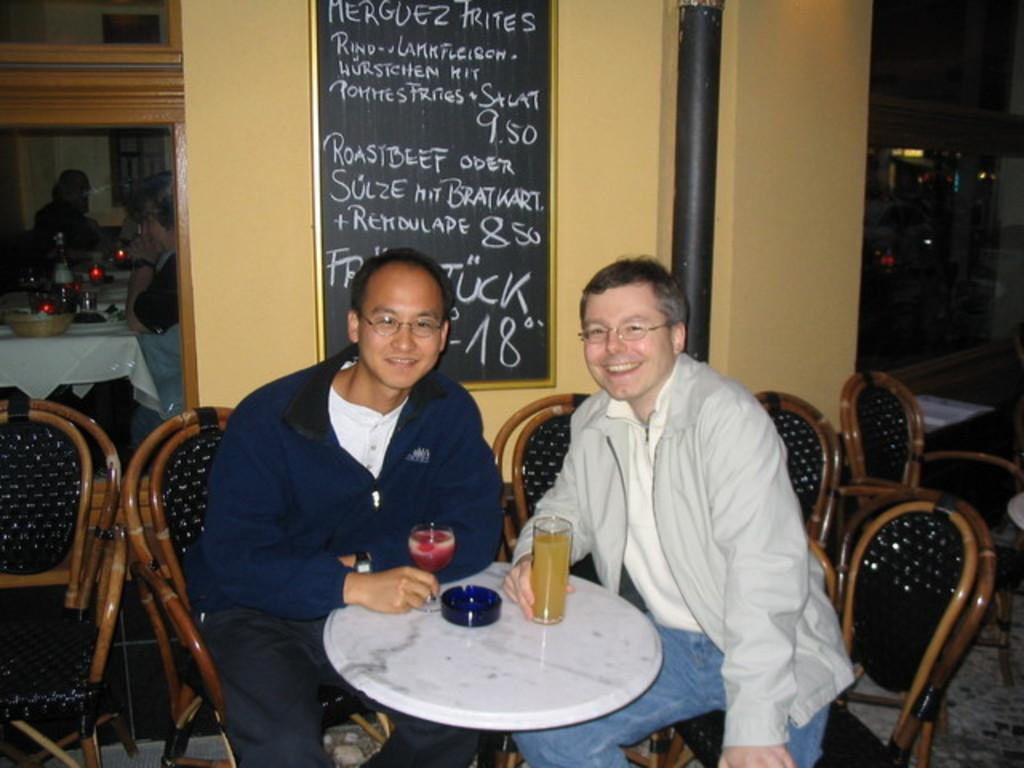What is the color of the door in the image? The door in the image is black. What is located next to the door in the image? There is a wall in the image. What are the two people in the image doing? The two people are sitting on chairs in the image. What is on the table in the image? There are glasses on the table in the image. Can you see a basin on the sidewalk in the image? There is no basin or sidewalk present in the image. What type of earth is visible in the image? The image does not depict any earth or soil; it features a black door, a wall, two people sitting on chairs, a table, and glasses. 